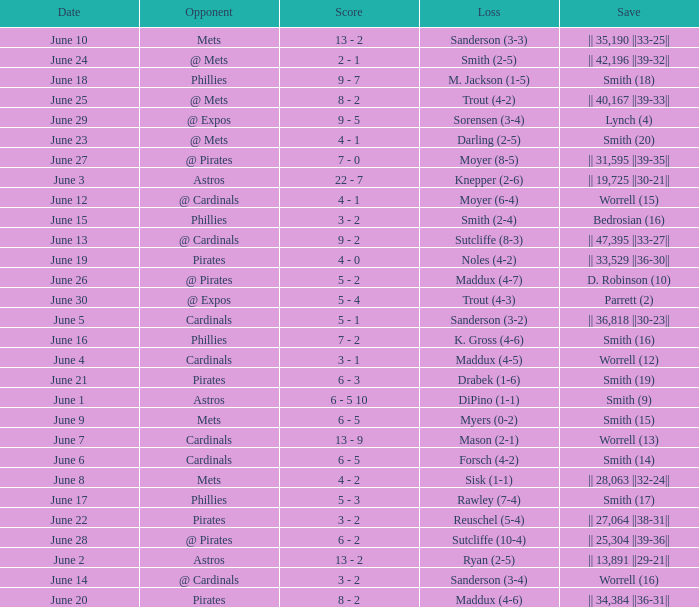On which day did the Chicago Cubs have a loss of trout (4-2)? June 25. 